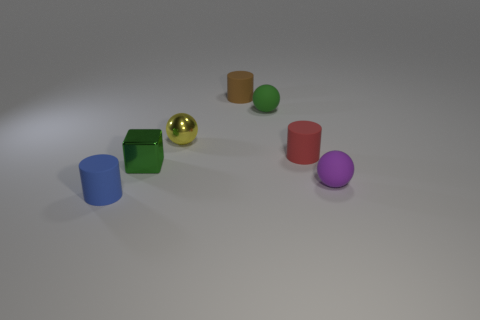What number of purple objects have the same material as the small red object?
Offer a terse response. 1. Is the small ball in front of the tiny green shiny block made of the same material as the tiny green object behind the tiny yellow thing?
Keep it short and to the point. Yes. There is a tiny rubber sphere on the left side of the small rubber ball in front of the red rubber thing; what number of tiny green shiny objects are to the right of it?
Provide a short and direct response. 0. There is a small cylinder behind the red rubber cylinder; is it the same color as the matte thing that is in front of the small purple sphere?
Provide a short and direct response. No. Are there any other things that are the same color as the block?
Ensure brevity in your answer.  Yes. What color is the cylinder that is on the left side of the small cylinder that is behind the red cylinder?
Your response must be concise. Blue. Are there any yellow things?
Your response must be concise. Yes. There is a thing that is behind the tiny metallic cube and to the left of the tiny brown matte thing; what color is it?
Make the answer very short. Yellow. Does the metallic sphere that is left of the tiny green sphere have the same size as the cylinder behind the tiny yellow metal thing?
Your response must be concise. Yes. How many other things are the same size as the purple sphere?
Make the answer very short. 6. 